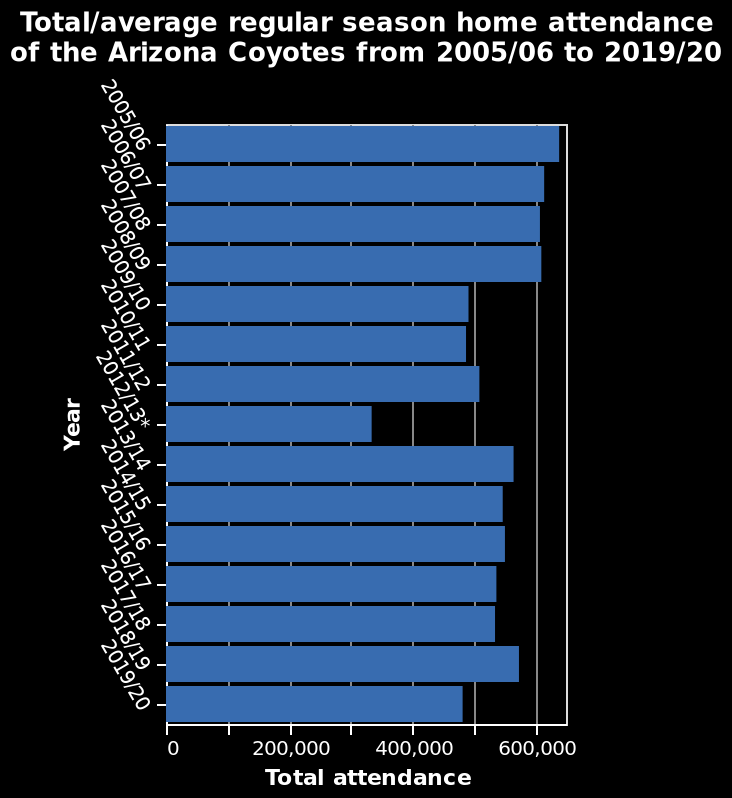<image>
Describe the following image in detail This is a bar diagram called Total/average regular season home attendance of the Arizona Coyotes from 2005/06 to 2019/20. Along the x-axis, Total attendance is defined on a linear scale from 0 to 600,000. The y-axis shows Year. How is the total attendance defined on the x-axis?  The total attendance is defined on a linear scale from 0 to 600,000 on the x-axis. What is the range of total attendance values on the x-axis?  The range of total attendance values on the x-axis is from 0 to 600,000. What does the y-axis represent?  The y-axis represents the years from 2005/06 to 2019/20. What was the year with the highest attendance?  The highest attendance was in 2005/06. please summary the statistics and relations of the chart The average attendance figures of the Arizona Coyotes has steadily declined from the year 2005 to 2019. Their highest figure in 2005 was almost double their lowest figure in 2012. 